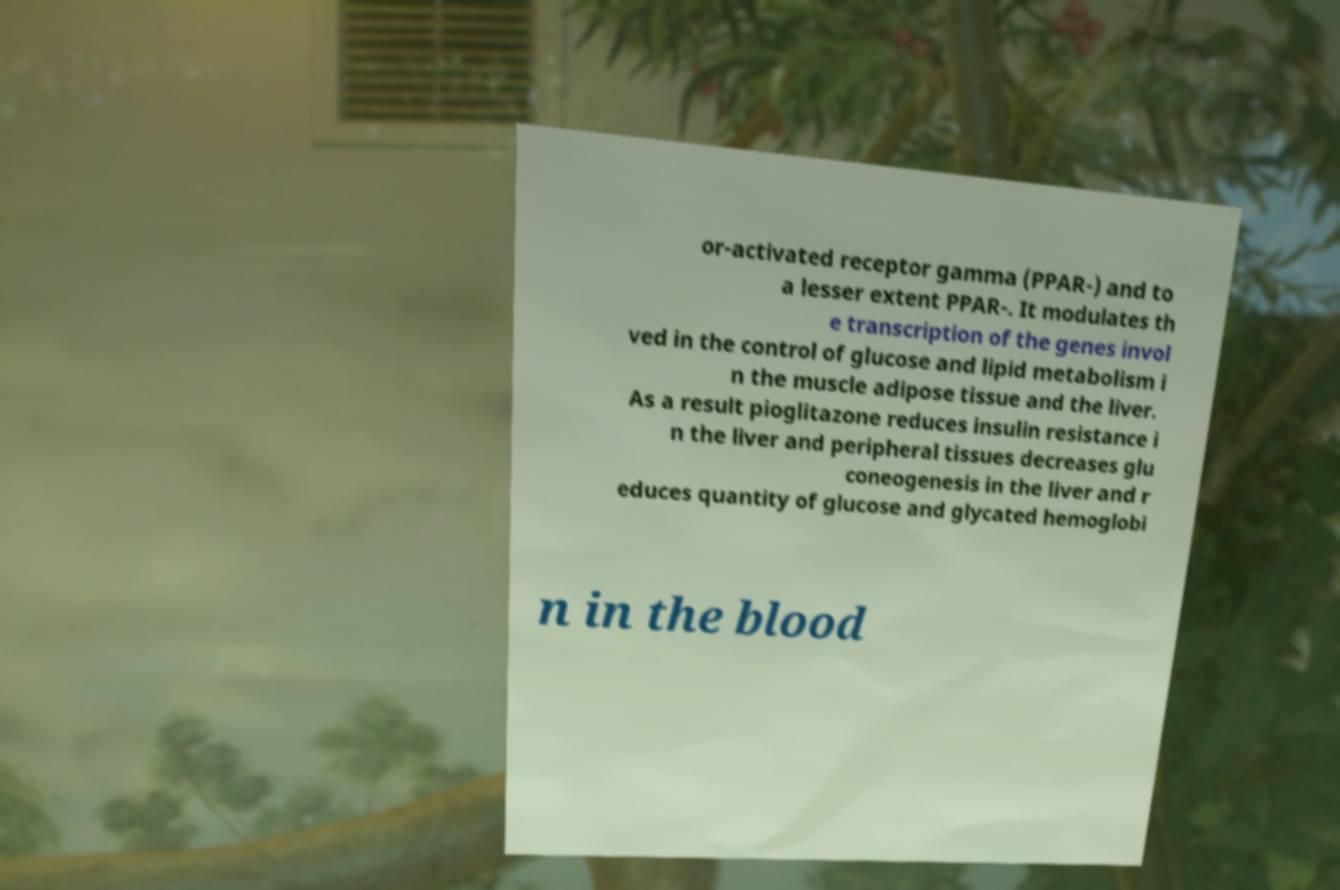Can you accurately transcribe the text from the provided image for me? or-activated receptor gamma (PPAR-) and to a lesser extent PPAR-. It modulates th e transcription of the genes invol ved in the control of glucose and lipid metabolism i n the muscle adipose tissue and the liver. As a result pioglitazone reduces insulin resistance i n the liver and peripheral tissues decreases glu coneogenesis in the liver and r educes quantity of glucose and glycated hemoglobi n in the blood 